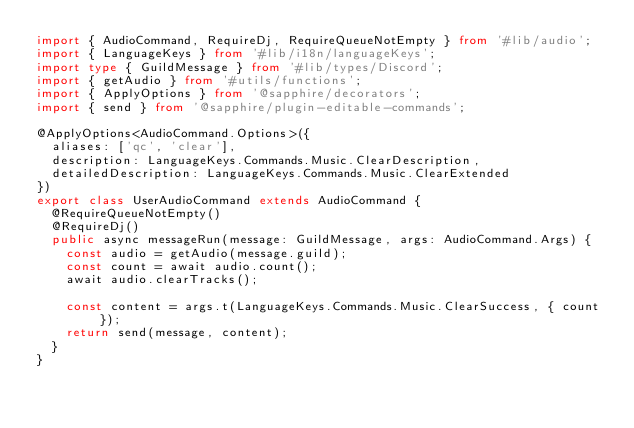<code> <loc_0><loc_0><loc_500><loc_500><_TypeScript_>import { AudioCommand, RequireDj, RequireQueueNotEmpty } from '#lib/audio';
import { LanguageKeys } from '#lib/i18n/languageKeys';
import type { GuildMessage } from '#lib/types/Discord';
import { getAudio } from '#utils/functions';
import { ApplyOptions } from '@sapphire/decorators';
import { send } from '@sapphire/plugin-editable-commands';

@ApplyOptions<AudioCommand.Options>({
	aliases: ['qc', 'clear'],
	description: LanguageKeys.Commands.Music.ClearDescription,
	detailedDescription: LanguageKeys.Commands.Music.ClearExtended
})
export class UserAudioCommand extends AudioCommand {
	@RequireQueueNotEmpty()
	@RequireDj()
	public async messageRun(message: GuildMessage, args: AudioCommand.Args) {
		const audio = getAudio(message.guild);
		const count = await audio.count();
		await audio.clearTracks();

		const content = args.t(LanguageKeys.Commands.Music.ClearSuccess, { count });
		return send(message, content);
	}
}
</code> 